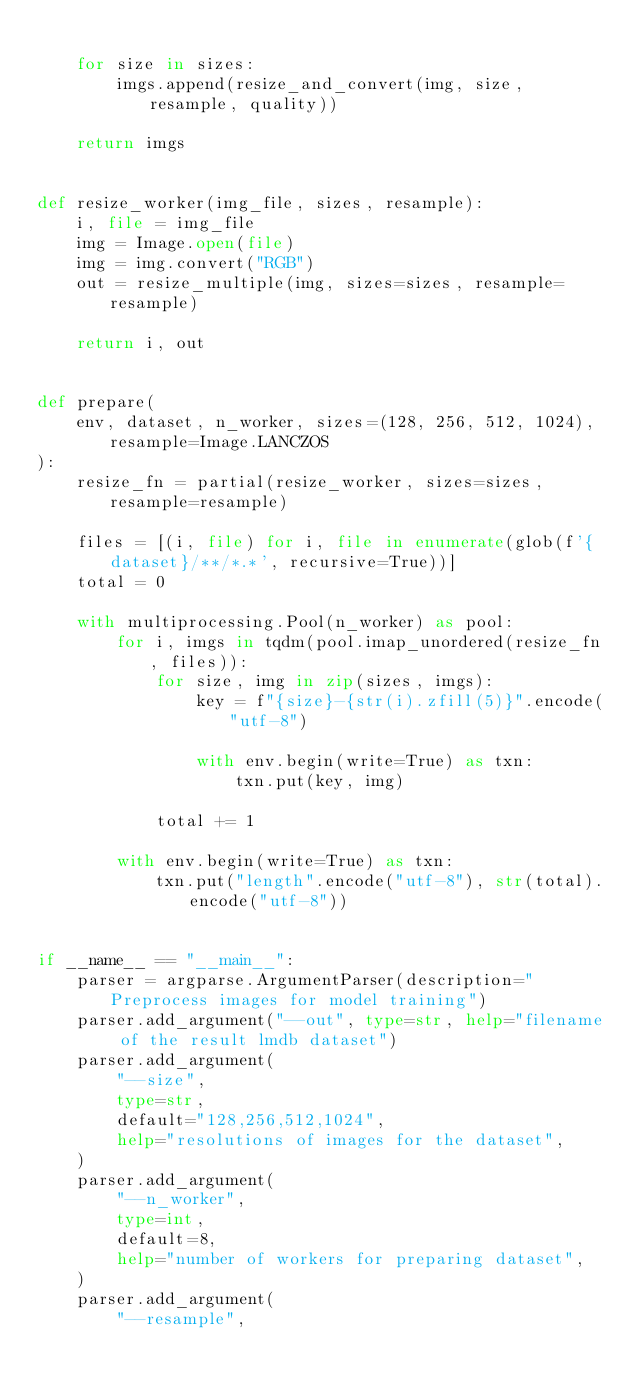Convert code to text. <code><loc_0><loc_0><loc_500><loc_500><_Python_>
    for size in sizes:
        imgs.append(resize_and_convert(img, size, resample, quality))

    return imgs


def resize_worker(img_file, sizes, resample):
    i, file = img_file
    img = Image.open(file)
    img = img.convert("RGB")
    out = resize_multiple(img, sizes=sizes, resample=resample)

    return i, out


def prepare(
    env, dataset, n_worker, sizes=(128, 256, 512, 1024), resample=Image.LANCZOS
):
    resize_fn = partial(resize_worker, sizes=sizes, resample=resample)

    files = [(i, file) for i, file in enumerate(glob(f'{dataset}/**/*.*', recursive=True))]
    total = 0

    with multiprocessing.Pool(n_worker) as pool:
        for i, imgs in tqdm(pool.imap_unordered(resize_fn, files)):
            for size, img in zip(sizes, imgs):
                key = f"{size}-{str(i).zfill(5)}".encode("utf-8")

                with env.begin(write=True) as txn:
                    txn.put(key, img)

            total += 1

        with env.begin(write=True) as txn:
            txn.put("length".encode("utf-8"), str(total).encode("utf-8"))


if __name__ == "__main__":
    parser = argparse.ArgumentParser(description="Preprocess images for model training")
    parser.add_argument("--out", type=str, help="filename of the result lmdb dataset")
    parser.add_argument(
        "--size",
        type=str,
        default="128,256,512,1024",
        help="resolutions of images for the dataset",
    )
    parser.add_argument(
        "--n_worker",
        type=int,
        default=8,
        help="number of workers for preparing dataset",
    )
    parser.add_argument(
        "--resample",</code> 